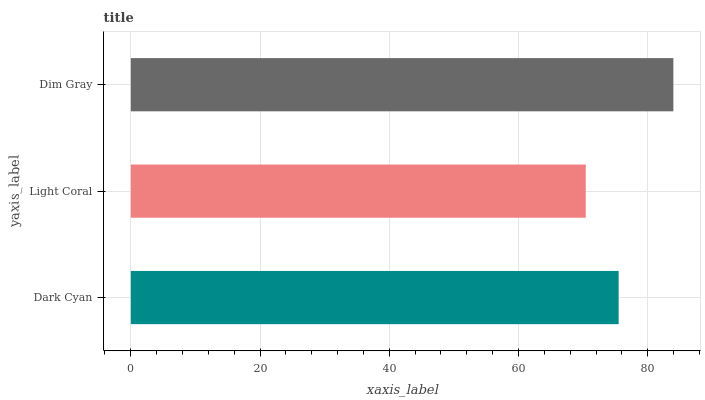Is Light Coral the minimum?
Answer yes or no. Yes. Is Dim Gray the maximum?
Answer yes or no. Yes. Is Dim Gray the minimum?
Answer yes or no. No. Is Light Coral the maximum?
Answer yes or no. No. Is Dim Gray greater than Light Coral?
Answer yes or no. Yes. Is Light Coral less than Dim Gray?
Answer yes or no. Yes. Is Light Coral greater than Dim Gray?
Answer yes or no. No. Is Dim Gray less than Light Coral?
Answer yes or no. No. Is Dark Cyan the high median?
Answer yes or no. Yes. Is Dark Cyan the low median?
Answer yes or no. Yes. Is Light Coral the high median?
Answer yes or no. No. Is Light Coral the low median?
Answer yes or no. No. 